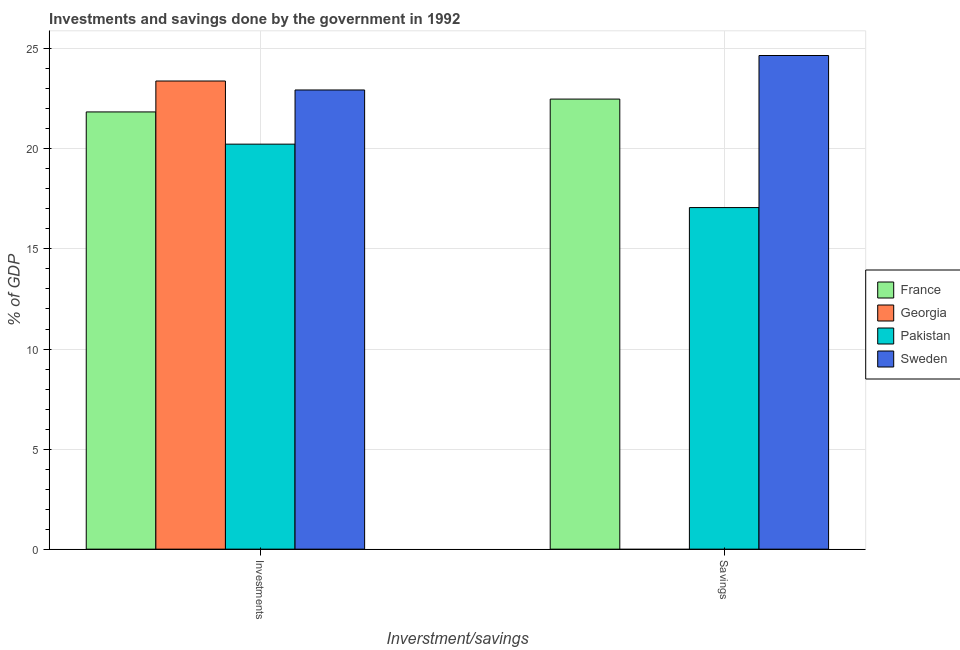How many different coloured bars are there?
Make the answer very short. 4. How many groups of bars are there?
Provide a succinct answer. 2. What is the label of the 2nd group of bars from the left?
Provide a short and direct response. Savings. What is the savings of government in Pakistan?
Give a very brief answer. 17.07. Across all countries, what is the maximum savings of government?
Your answer should be very brief. 24.67. Across all countries, what is the minimum savings of government?
Offer a very short reply. 0. In which country was the investments of government maximum?
Your response must be concise. Georgia. What is the total savings of government in the graph?
Make the answer very short. 64.22. What is the difference between the investments of government in Sweden and that in Georgia?
Provide a short and direct response. -0.45. What is the difference between the savings of government in Sweden and the investments of government in Georgia?
Provide a short and direct response. 1.27. What is the average savings of government per country?
Give a very brief answer. 16.06. What is the difference between the savings of government and investments of government in Sweden?
Ensure brevity in your answer.  1.72. In how many countries, is the savings of government greater than 20 %?
Provide a succinct answer. 2. What is the ratio of the investments of government in Pakistan to that in Sweden?
Offer a terse response. 0.88. Is the savings of government in France less than that in Pakistan?
Provide a short and direct response. No. In how many countries, is the investments of government greater than the average investments of government taken over all countries?
Your response must be concise. 2. How many bars are there?
Your response must be concise. 7. Are all the bars in the graph horizontal?
Ensure brevity in your answer.  No. Are the values on the major ticks of Y-axis written in scientific E-notation?
Your answer should be compact. No. Does the graph contain any zero values?
Offer a very short reply. Yes. Does the graph contain grids?
Make the answer very short. Yes. Where does the legend appear in the graph?
Keep it short and to the point. Center right. How many legend labels are there?
Provide a succinct answer. 4. How are the legend labels stacked?
Provide a short and direct response. Vertical. What is the title of the graph?
Provide a succinct answer. Investments and savings done by the government in 1992. What is the label or title of the X-axis?
Give a very brief answer. Inverstment/savings. What is the label or title of the Y-axis?
Your answer should be compact. % of GDP. What is the % of GDP of France in Investments?
Make the answer very short. 21.85. What is the % of GDP in Georgia in Investments?
Your response must be concise. 23.39. What is the % of GDP in Pakistan in Investments?
Offer a terse response. 20.24. What is the % of GDP of Sweden in Investments?
Make the answer very short. 22.94. What is the % of GDP in France in Savings?
Your response must be concise. 22.49. What is the % of GDP of Pakistan in Savings?
Provide a short and direct response. 17.07. What is the % of GDP of Sweden in Savings?
Offer a terse response. 24.67. Across all Inverstment/savings, what is the maximum % of GDP in France?
Give a very brief answer. 22.49. Across all Inverstment/savings, what is the maximum % of GDP of Georgia?
Make the answer very short. 23.39. Across all Inverstment/savings, what is the maximum % of GDP in Pakistan?
Your answer should be compact. 20.24. Across all Inverstment/savings, what is the maximum % of GDP of Sweden?
Keep it short and to the point. 24.67. Across all Inverstment/savings, what is the minimum % of GDP in France?
Your answer should be compact. 21.85. Across all Inverstment/savings, what is the minimum % of GDP of Pakistan?
Provide a short and direct response. 17.07. Across all Inverstment/savings, what is the minimum % of GDP in Sweden?
Your response must be concise. 22.94. What is the total % of GDP in France in the graph?
Give a very brief answer. 44.34. What is the total % of GDP of Georgia in the graph?
Ensure brevity in your answer.  23.39. What is the total % of GDP of Pakistan in the graph?
Provide a succinct answer. 37.3. What is the total % of GDP of Sweden in the graph?
Ensure brevity in your answer.  47.61. What is the difference between the % of GDP of France in Investments and that in Savings?
Your response must be concise. -0.64. What is the difference between the % of GDP in Pakistan in Investments and that in Savings?
Your answer should be compact. 3.17. What is the difference between the % of GDP in Sweden in Investments and that in Savings?
Your response must be concise. -1.72. What is the difference between the % of GDP of France in Investments and the % of GDP of Pakistan in Savings?
Make the answer very short. 4.78. What is the difference between the % of GDP of France in Investments and the % of GDP of Sweden in Savings?
Give a very brief answer. -2.82. What is the difference between the % of GDP in Georgia in Investments and the % of GDP in Pakistan in Savings?
Offer a very short reply. 6.32. What is the difference between the % of GDP in Georgia in Investments and the % of GDP in Sweden in Savings?
Provide a short and direct response. -1.27. What is the difference between the % of GDP of Pakistan in Investments and the % of GDP of Sweden in Savings?
Keep it short and to the point. -4.43. What is the average % of GDP in France per Inverstment/savings?
Offer a very short reply. 22.17. What is the average % of GDP in Georgia per Inverstment/savings?
Ensure brevity in your answer.  11.7. What is the average % of GDP of Pakistan per Inverstment/savings?
Make the answer very short. 18.65. What is the average % of GDP in Sweden per Inverstment/savings?
Your answer should be compact. 23.8. What is the difference between the % of GDP of France and % of GDP of Georgia in Investments?
Your answer should be very brief. -1.54. What is the difference between the % of GDP of France and % of GDP of Pakistan in Investments?
Make the answer very short. 1.61. What is the difference between the % of GDP of France and % of GDP of Sweden in Investments?
Give a very brief answer. -1.1. What is the difference between the % of GDP of Georgia and % of GDP of Pakistan in Investments?
Provide a short and direct response. 3.15. What is the difference between the % of GDP in Georgia and % of GDP in Sweden in Investments?
Provide a short and direct response. 0.45. What is the difference between the % of GDP in Pakistan and % of GDP in Sweden in Investments?
Keep it short and to the point. -2.71. What is the difference between the % of GDP in France and % of GDP in Pakistan in Savings?
Your answer should be compact. 5.42. What is the difference between the % of GDP of France and % of GDP of Sweden in Savings?
Your response must be concise. -2.18. What is the difference between the % of GDP in Pakistan and % of GDP in Sweden in Savings?
Ensure brevity in your answer.  -7.6. What is the ratio of the % of GDP in France in Investments to that in Savings?
Ensure brevity in your answer.  0.97. What is the ratio of the % of GDP of Pakistan in Investments to that in Savings?
Give a very brief answer. 1.19. What is the ratio of the % of GDP in Sweden in Investments to that in Savings?
Provide a short and direct response. 0.93. What is the difference between the highest and the second highest % of GDP in France?
Your answer should be very brief. 0.64. What is the difference between the highest and the second highest % of GDP in Pakistan?
Your response must be concise. 3.17. What is the difference between the highest and the second highest % of GDP of Sweden?
Keep it short and to the point. 1.72. What is the difference between the highest and the lowest % of GDP of France?
Your response must be concise. 0.64. What is the difference between the highest and the lowest % of GDP in Georgia?
Your response must be concise. 23.39. What is the difference between the highest and the lowest % of GDP in Pakistan?
Your response must be concise. 3.17. What is the difference between the highest and the lowest % of GDP of Sweden?
Offer a very short reply. 1.72. 